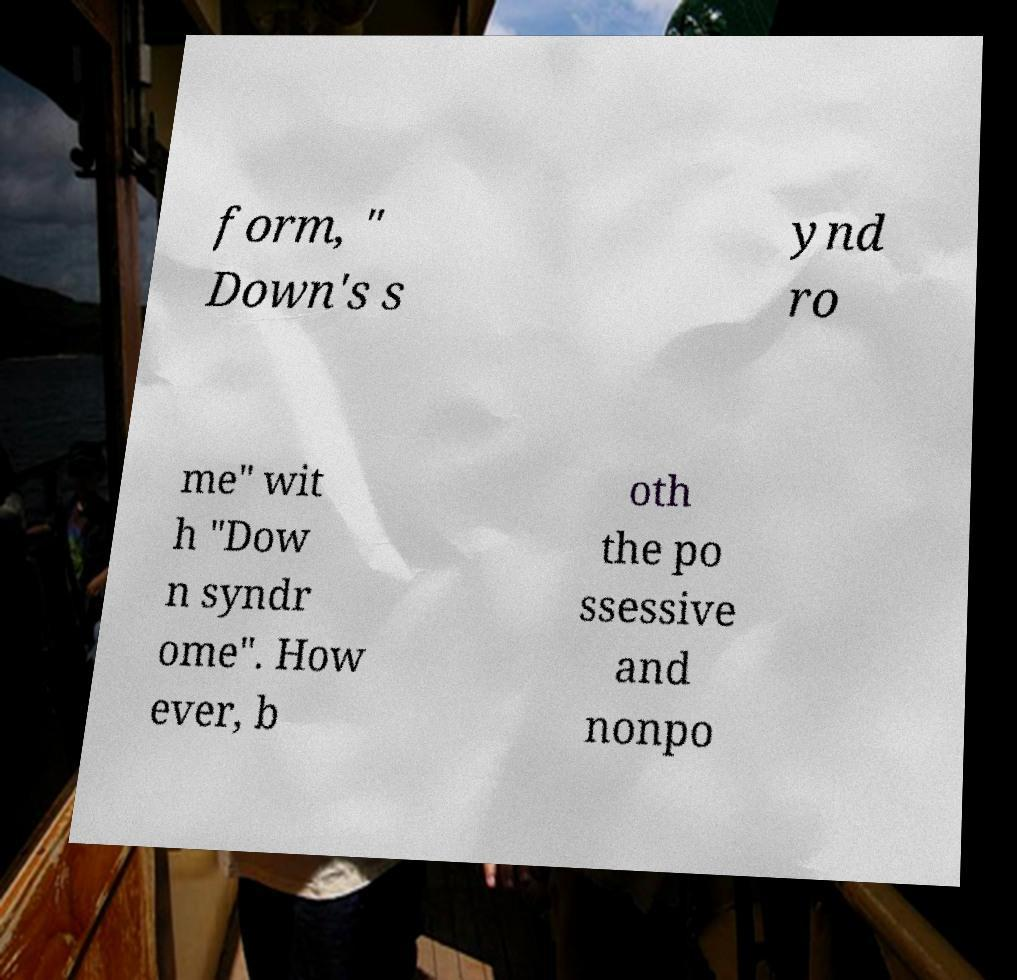Can you read and provide the text displayed in the image?This photo seems to have some interesting text. Can you extract and type it out for me? form, " Down's s ynd ro me" wit h "Dow n syndr ome". How ever, b oth the po ssessive and nonpo 